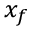Convert formula to latex. <formula><loc_0><loc_0><loc_500><loc_500>x _ { f }</formula> 